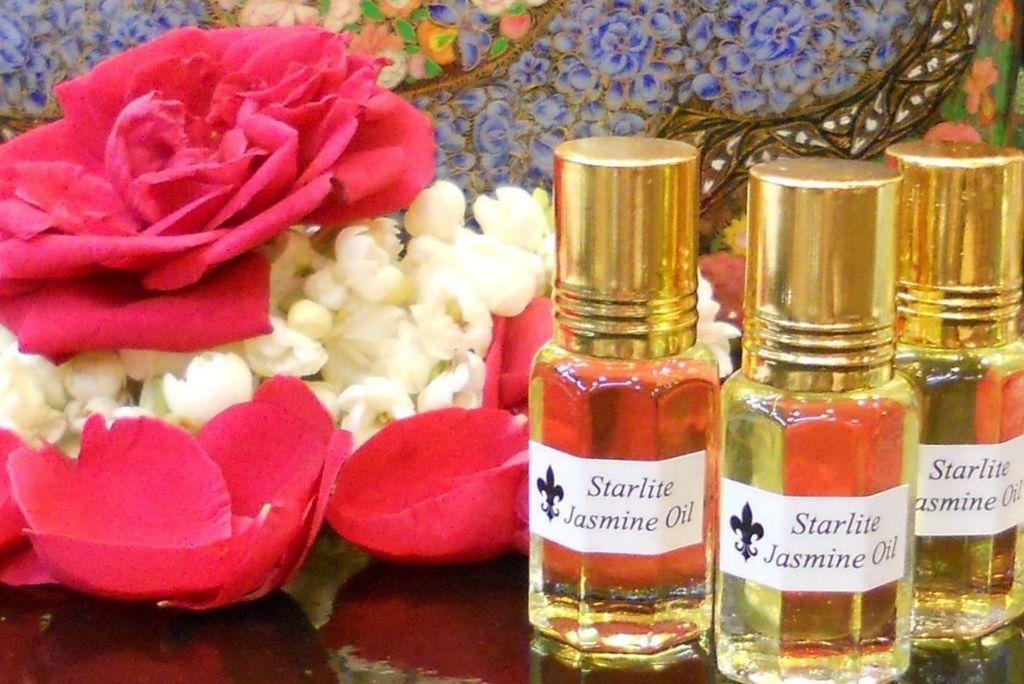<image>
Write a terse but informative summary of the picture. A table is set with flowers and three bottes of Starlite Jasmine Oil. 